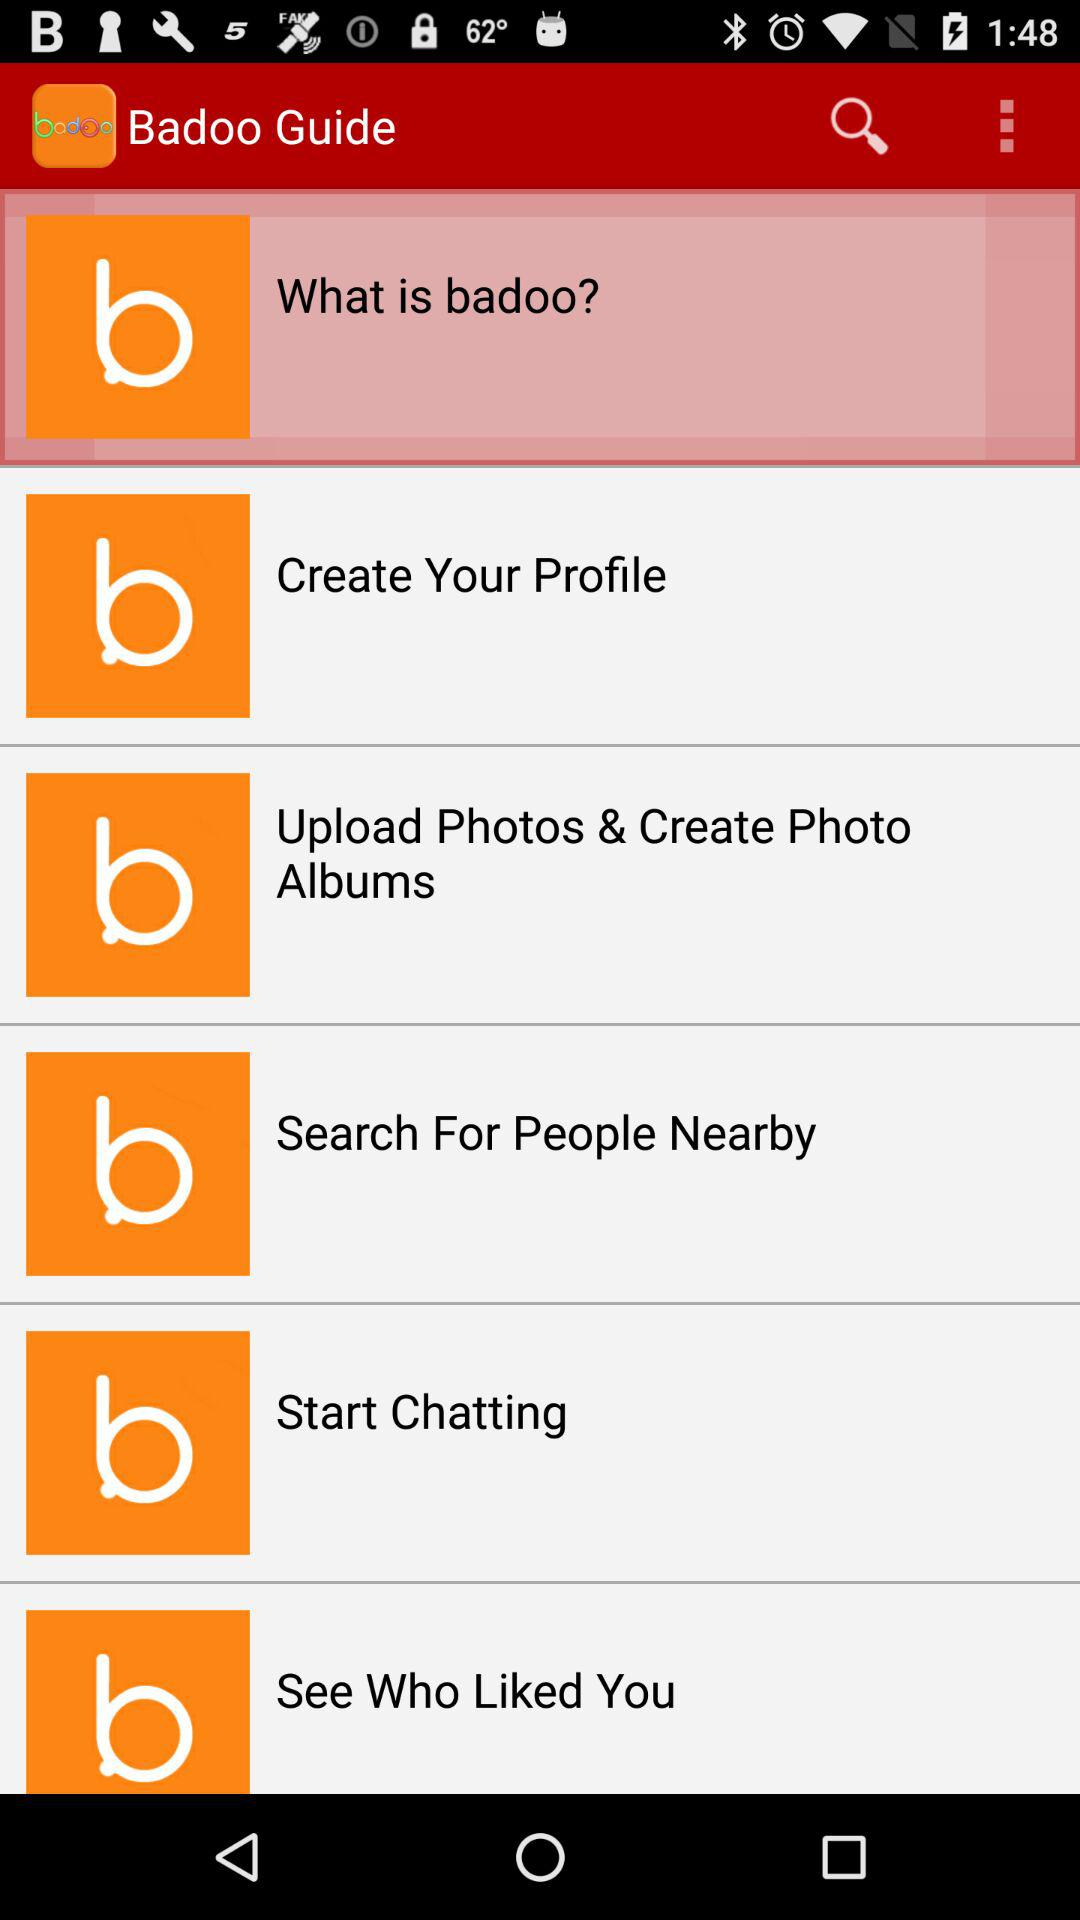What is the name of the application? The name of the application is "Free Badoo Chat Meet People Tips". 